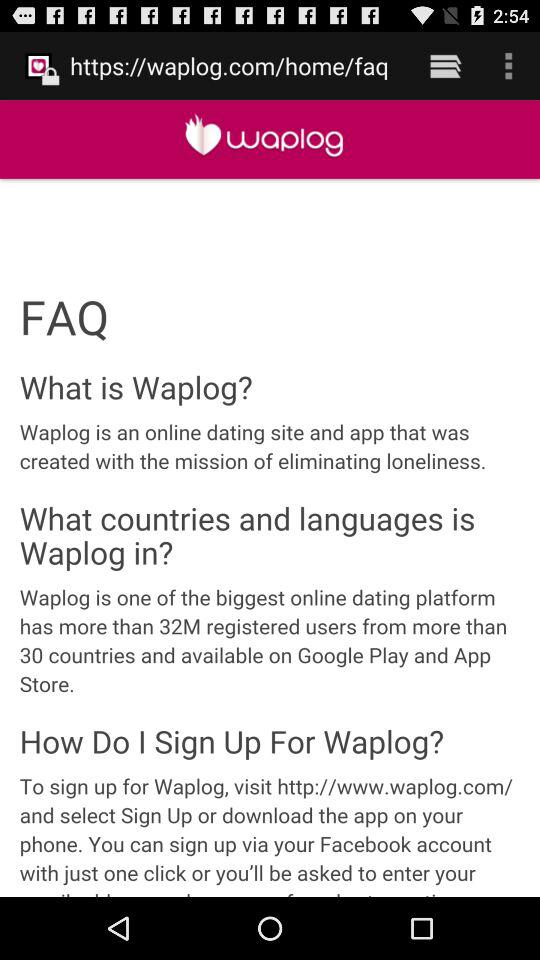How many countries is Waplog available in?
Answer the question using a single word or phrase. More than 30 